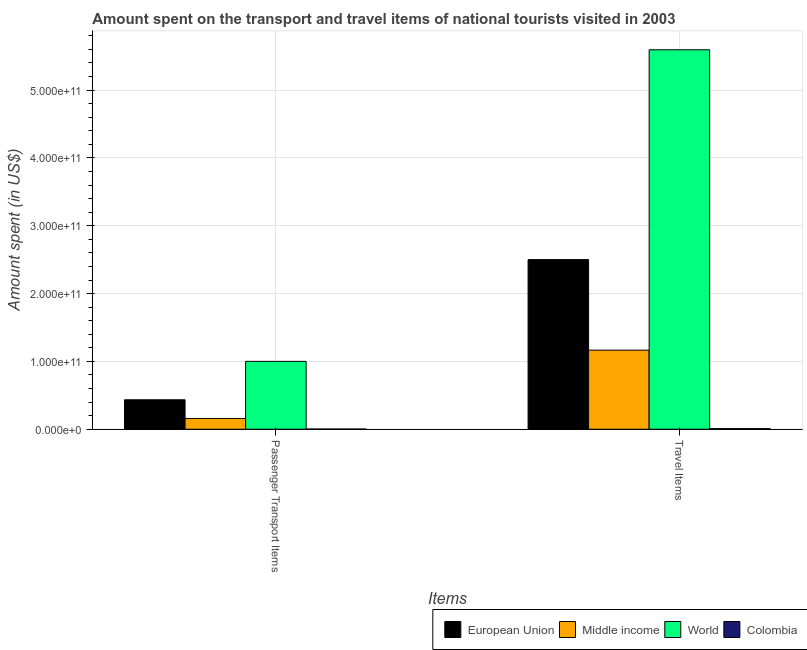How many different coloured bars are there?
Keep it short and to the point. 4. How many groups of bars are there?
Your response must be concise. 2. How many bars are there on the 1st tick from the right?
Your answer should be very brief. 4. What is the label of the 2nd group of bars from the left?
Make the answer very short. Travel Items. What is the amount spent on passenger transport items in Colombia?
Provide a short and direct response. 2.98e+08. Across all countries, what is the maximum amount spent on passenger transport items?
Offer a very short reply. 1.00e+11. Across all countries, what is the minimum amount spent in travel items?
Give a very brief answer. 8.93e+08. What is the total amount spent in travel items in the graph?
Ensure brevity in your answer.  9.27e+11. What is the difference between the amount spent in travel items in Middle income and that in European Union?
Offer a terse response. -1.33e+11. What is the difference between the amount spent on passenger transport items in European Union and the amount spent in travel items in World?
Your answer should be compact. -5.16e+11. What is the average amount spent in travel items per country?
Offer a very short reply. 2.32e+11. What is the difference between the amount spent in travel items and amount spent on passenger transport items in World?
Provide a succinct answer. 4.59e+11. In how many countries, is the amount spent on passenger transport items greater than 260000000000 US$?
Ensure brevity in your answer.  0. What is the ratio of the amount spent in travel items in European Union to that in Colombia?
Offer a very short reply. 280.01. Is the amount spent on passenger transport items in Middle income less than that in European Union?
Ensure brevity in your answer.  Yes. What does the 1st bar from the left in Travel Items represents?
Your response must be concise. European Union. How many bars are there?
Keep it short and to the point. 8. Are all the bars in the graph horizontal?
Your response must be concise. No. How many countries are there in the graph?
Offer a very short reply. 4. What is the difference between two consecutive major ticks on the Y-axis?
Give a very brief answer. 1.00e+11. Are the values on the major ticks of Y-axis written in scientific E-notation?
Offer a terse response. Yes. Does the graph contain any zero values?
Ensure brevity in your answer.  No. Does the graph contain grids?
Give a very brief answer. Yes. Where does the legend appear in the graph?
Offer a very short reply. Bottom right. How are the legend labels stacked?
Offer a very short reply. Horizontal. What is the title of the graph?
Give a very brief answer. Amount spent on the transport and travel items of national tourists visited in 2003. Does "Italy" appear as one of the legend labels in the graph?
Make the answer very short. No. What is the label or title of the X-axis?
Offer a very short reply. Items. What is the label or title of the Y-axis?
Your answer should be compact. Amount spent (in US$). What is the Amount spent (in US$) in European Union in Passenger Transport Items?
Give a very brief answer. 4.34e+1. What is the Amount spent (in US$) of Middle income in Passenger Transport Items?
Provide a succinct answer. 1.59e+1. What is the Amount spent (in US$) of World in Passenger Transport Items?
Give a very brief answer. 1.00e+11. What is the Amount spent (in US$) in Colombia in Passenger Transport Items?
Give a very brief answer. 2.98e+08. What is the Amount spent (in US$) of European Union in Travel Items?
Offer a terse response. 2.50e+11. What is the Amount spent (in US$) of Middle income in Travel Items?
Your response must be concise. 1.17e+11. What is the Amount spent (in US$) in World in Travel Items?
Your response must be concise. 5.59e+11. What is the Amount spent (in US$) of Colombia in Travel Items?
Provide a short and direct response. 8.93e+08. Across all Items, what is the maximum Amount spent (in US$) in European Union?
Ensure brevity in your answer.  2.50e+11. Across all Items, what is the maximum Amount spent (in US$) of Middle income?
Provide a succinct answer. 1.17e+11. Across all Items, what is the maximum Amount spent (in US$) in World?
Make the answer very short. 5.59e+11. Across all Items, what is the maximum Amount spent (in US$) of Colombia?
Ensure brevity in your answer.  8.93e+08. Across all Items, what is the minimum Amount spent (in US$) in European Union?
Offer a terse response. 4.34e+1. Across all Items, what is the minimum Amount spent (in US$) in Middle income?
Ensure brevity in your answer.  1.59e+1. Across all Items, what is the minimum Amount spent (in US$) in World?
Your answer should be compact. 1.00e+11. Across all Items, what is the minimum Amount spent (in US$) in Colombia?
Give a very brief answer. 2.98e+08. What is the total Amount spent (in US$) in European Union in the graph?
Your answer should be very brief. 2.93e+11. What is the total Amount spent (in US$) in Middle income in the graph?
Give a very brief answer. 1.32e+11. What is the total Amount spent (in US$) of World in the graph?
Provide a succinct answer. 6.59e+11. What is the total Amount spent (in US$) in Colombia in the graph?
Your answer should be very brief. 1.19e+09. What is the difference between the Amount spent (in US$) in European Union in Passenger Transport Items and that in Travel Items?
Offer a very short reply. -2.07e+11. What is the difference between the Amount spent (in US$) in Middle income in Passenger Transport Items and that in Travel Items?
Ensure brevity in your answer.  -1.01e+11. What is the difference between the Amount spent (in US$) in World in Passenger Transport Items and that in Travel Items?
Your answer should be compact. -4.59e+11. What is the difference between the Amount spent (in US$) of Colombia in Passenger Transport Items and that in Travel Items?
Offer a very short reply. -5.95e+08. What is the difference between the Amount spent (in US$) in European Union in Passenger Transport Items and the Amount spent (in US$) in Middle income in Travel Items?
Provide a short and direct response. -7.32e+1. What is the difference between the Amount spent (in US$) in European Union in Passenger Transport Items and the Amount spent (in US$) in World in Travel Items?
Keep it short and to the point. -5.16e+11. What is the difference between the Amount spent (in US$) in European Union in Passenger Transport Items and the Amount spent (in US$) in Colombia in Travel Items?
Make the answer very short. 4.25e+1. What is the difference between the Amount spent (in US$) in Middle income in Passenger Transport Items and the Amount spent (in US$) in World in Travel Items?
Make the answer very short. -5.44e+11. What is the difference between the Amount spent (in US$) of Middle income in Passenger Transport Items and the Amount spent (in US$) of Colombia in Travel Items?
Make the answer very short. 1.50e+1. What is the difference between the Amount spent (in US$) of World in Passenger Transport Items and the Amount spent (in US$) of Colombia in Travel Items?
Offer a terse response. 9.92e+1. What is the average Amount spent (in US$) in European Union per Items?
Keep it short and to the point. 1.47e+11. What is the average Amount spent (in US$) in Middle income per Items?
Keep it short and to the point. 6.62e+1. What is the average Amount spent (in US$) of World per Items?
Make the answer very short. 3.30e+11. What is the average Amount spent (in US$) in Colombia per Items?
Offer a terse response. 5.96e+08. What is the difference between the Amount spent (in US$) in European Union and Amount spent (in US$) in Middle income in Passenger Transport Items?
Provide a short and direct response. 2.76e+1. What is the difference between the Amount spent (in US$) of European Union and Amount spent (in US$) of World in Passenger Transport Items?
Provide a short and direct response. -5.67e+1. What is the difference between the Amount spent (in US$) in European Union and Amount spent (in US$) in Colombia in Passenger Transport Items?
Your answer should be compact. 4.31e+1. What is the difference between the Amount spent (in US$) of Middle income and Amount spent (in US$) of World in Passenger Transport Items?
Offer a very short reply. -8.42e+1. What is the difference between the Amount spent (in US$) in Middle income and Amount spent (in US$) in Colombia in Passenger Transport Items?
Make the answer very short. 1.56e+1. What is the difference between the Amount spent (in US$) in World and Amount spent (in US$) in Colombia in Passenger Transport Items?
Your answer should be very brief. 9.98e+1. What is the difference between the Amount spent (in US$) of European Union and Amount spent (in US$) of Middle income in Travel Items?
Your response must be concise. 1.33e+11. What is the difference between the Amount spent (in US$) of European Union and Amount spent (in US$) of World in Travel Items?
Your answer should be very brief. -3.09e+11. What is the difference between the Amount spent (in US$) in European Union and Amount spent (in US$) in Colombia in Travel Items?
Your response must be concise. 2.49e+11. What is the difference between the Amount spent (in US$) of Middle income and Amount spent (in US$) of World in Travel Items?
Provide a succinct answer. -4.43e+11. What is the difference between the Amount spent (in US$) in Middle income and Amount spent (in US$) in Colombia in Travel Items?
Your answer should be compact. 1.16e+11. What is the difference between the Amount spent (in US$) of World and Amount spent (in US$) of Colombia in Travel Items?
Keep it short and to the point. 5.59e+11. What is the ratio of the Amount spent (in US$) in European Union in Passenger Transport Items to that in Travel Items?
Give a very brief answer. 0.17. What is the ratio of the Amount spent (in US$) of Middle income in Passenger Transport Items to that in Travel Items?
Provide a succinct answer. 0.14. What is the ratio of the Amount spent (in US$) in World in Passenger Transport Items to that in Travel Items?
Make the answer very short. 0.18. What is the ratio of the Amount spent (in US$) in Colombia in Passenger Transport Items to that in Travel Items?
Provide a short and direct response. 0.33. What is the difference between the highest and the second highest Amount spent (in US$) in European Union?
Make the answer very short. 2.07e+11. What is the difference between the highest and the second highest Amount spent (in US$) of Middle income?
Keep it short and to the point. 1.01e+11. What is the difference between the highest and the second highest Amount spent (in US$) of World?
Provide a succinct answer. 4.59e+11. What is the difference between the highest and the second highest Amount spent (in US$) in Colombia?
Make the answer very short. 5.95e+08. What is the difference between the highest and the lowest Amount spent (in US$) in European Union?
Provide a short and direct response. 2.07e+11. What is the difference between the highest and the lowest Amount spent (in US$) in Middle income?
Your answer should be compact. 1.01e+11. What is the difference between the highest and the lowest Amount spent (in US$) of World?
Your answer should be compact. 4.59e+11. What is the difference between the highest and the lowest Amount spent (in US$) in Colombia?
Your answer should be compact. 5.95e+08. 